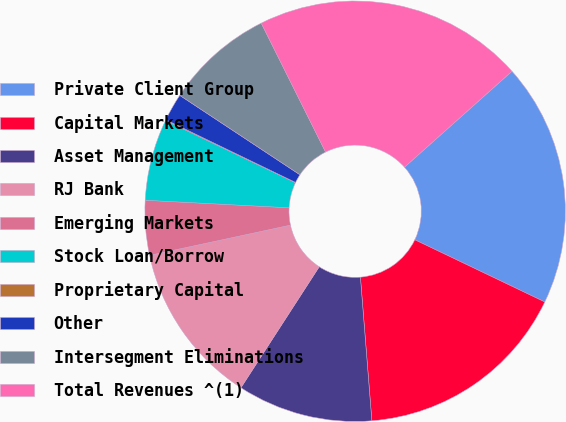<chart> <loc_0><loc_0><loc_500><loc_500><pie_chart><fcel>Private Client Group<fcel>Capital Markets<fcel>Asset Management<fcel>RJ Bank<fcel>Emerging Markets<fcel>Stock Loan/Borrow<fcel>Proprietary Capital<fcel>Other<fcel>Intersegment Eliminations<fcel>Total Revenues ^(1)<nl><fcel>18.7%<fcel>16.63%<fcel>10.41%<fcel>12.49%<fcel>4.2%<fcel>6.27%<fcel>0.06%<fcel>2.13%<fcel>8.34%<fcel>20.77%<nl></chart> 